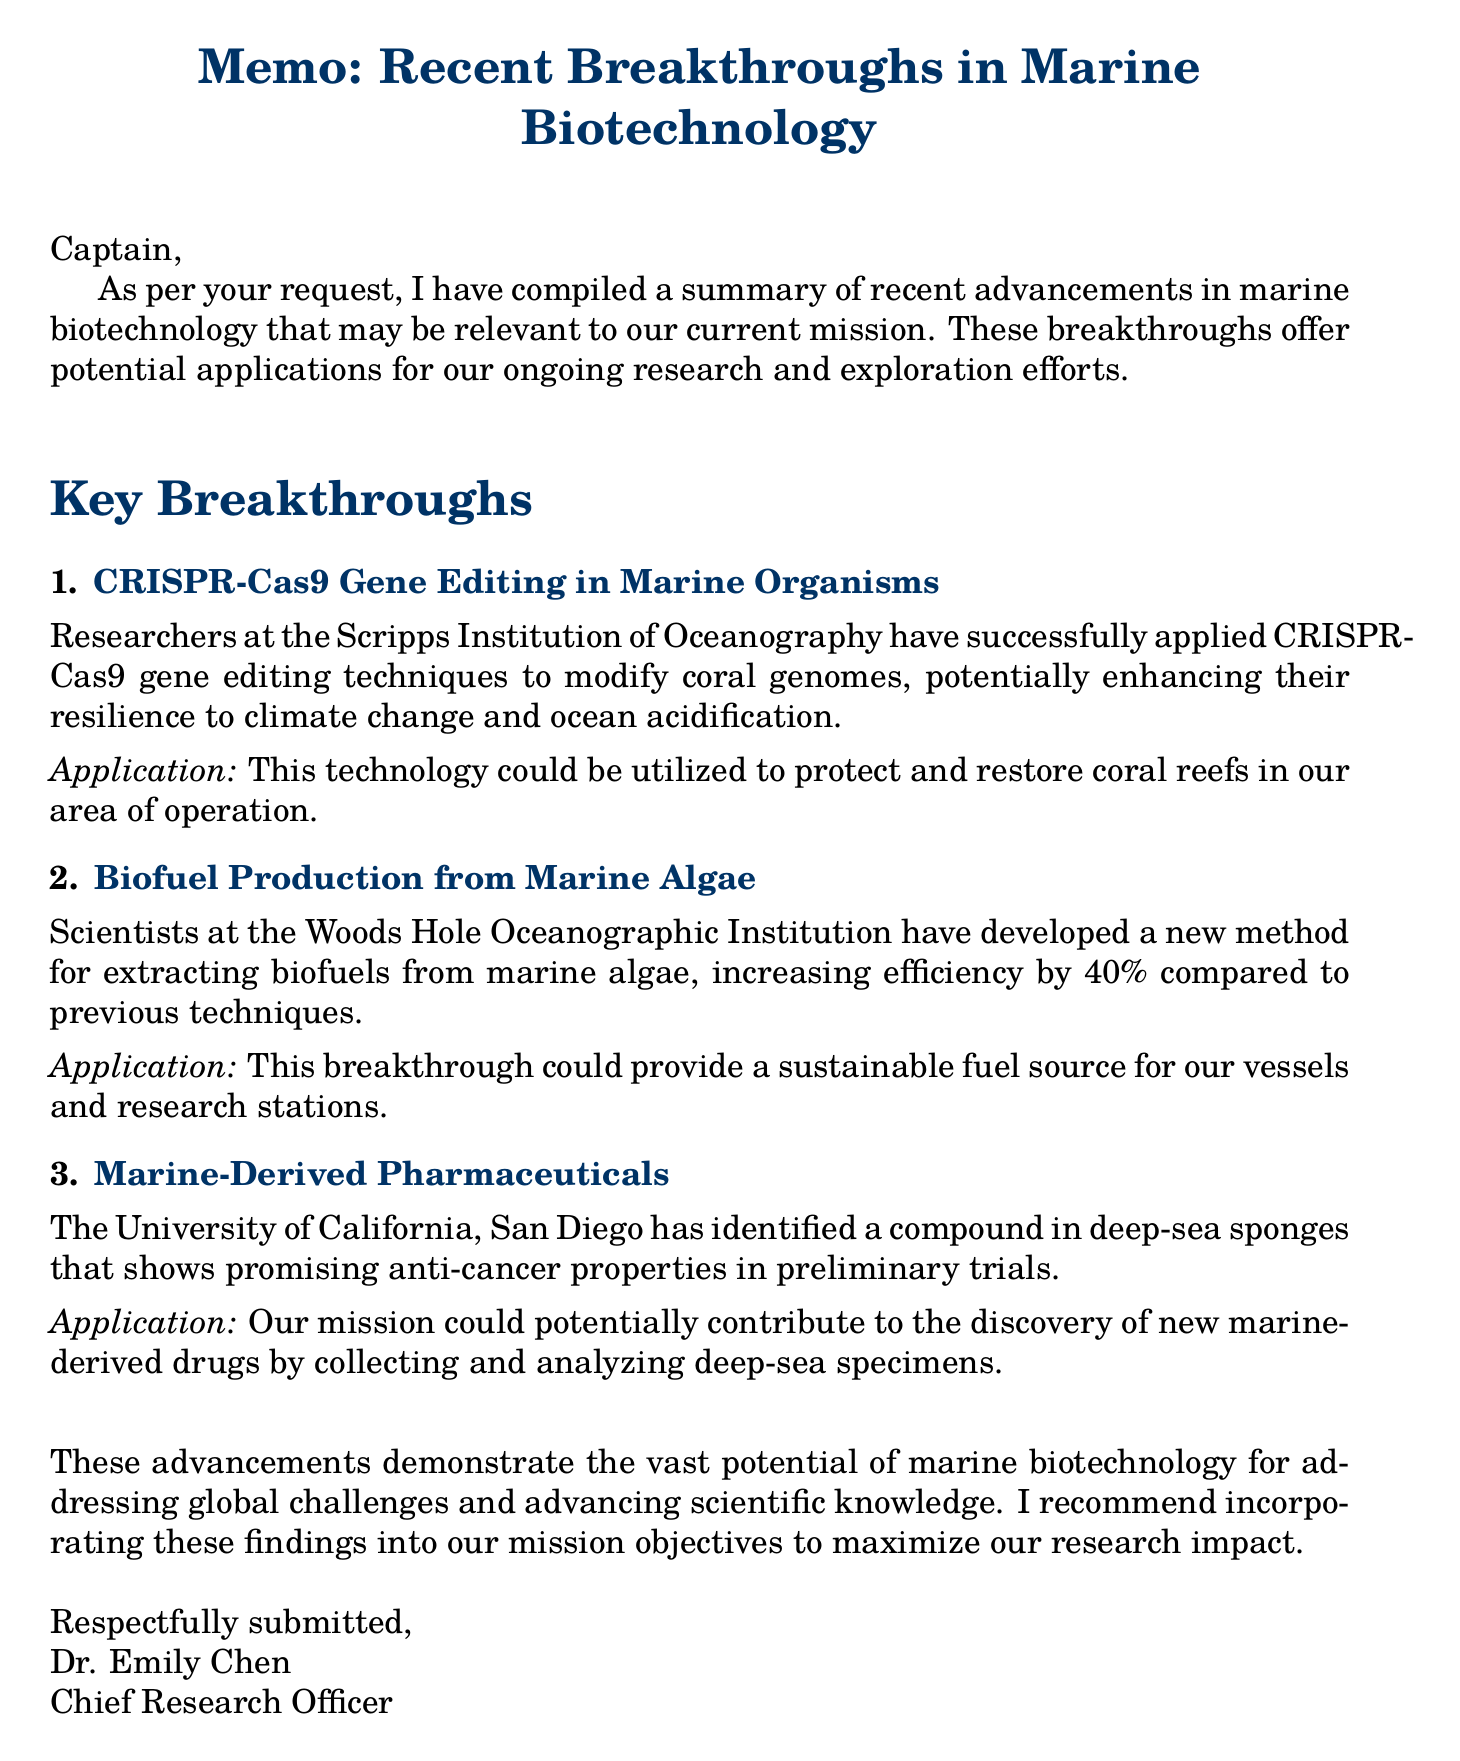What gene editing technique was used on coral genomes? The document mentions that researchers applied CRISPR-Cas9 gene editing techniques to modify coral genomes.
Answer: CRISPR-Cas9 What institution developed a method for extracting biofuels from algae? The Woods Hole Oceanographic Institution is identified as the institution that developed the new method for biofuel extraction from marine algae.
Answer: Woods Hole Oceanographic Institution What is the percentage increase in efficiency for extracting biofuels from marine algae? The document states that the new method increases efficiency by 40% compared to previous techniques.
Answer: 40% Which university identified a compound in deep-sea sponges with anti-cancer properties? The document lists the University of California, San Diego as the institution that identified the promising anti-cancer compound.
Answer: University of California, San Diego What potential application is suggested for the CRISPR-Cas9 technology? The technology could be utilized to protect and restore coral reefs in the area of operation.
Answer: Protect and restore coral reefs What is the main focus of the memo? The memo focuses on summarizing recent breakthroughs in marine biotechnology relevant to the current mission.
Answer: Recent breakthroughs in marine biotechnology Who submitted the memo? Dr. Emily Chen, the Chief Research Officer, submitted the memo.
Answer: Dr. Emily Chen What type of document is this? The document is a memo that summarizes research findings.
Answer: Memo 